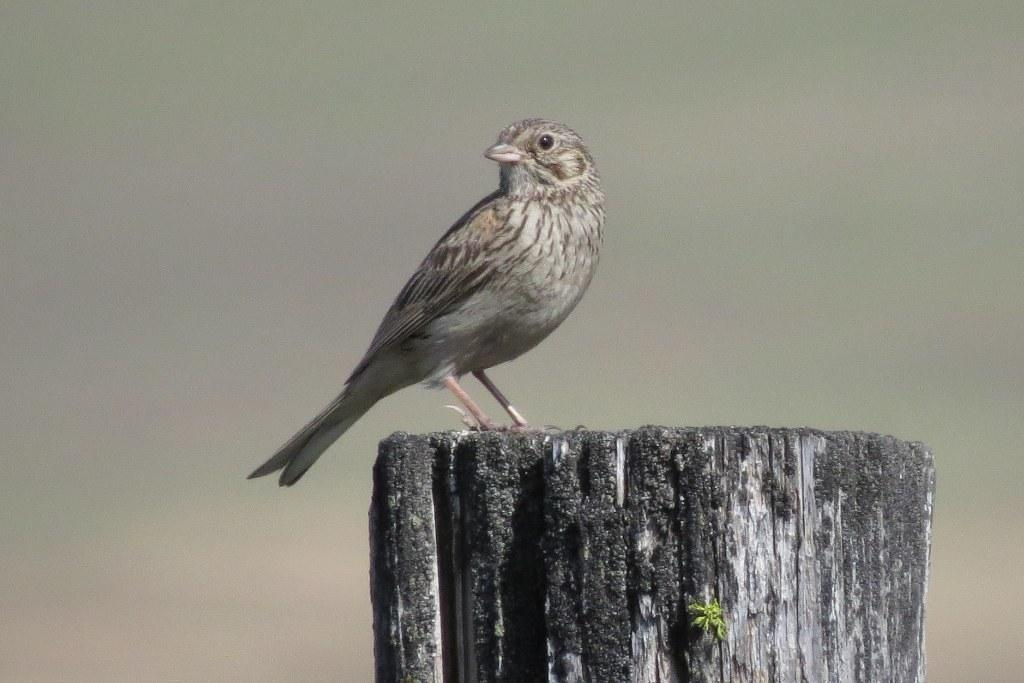What type of animal is in the image? There is a bird in the image. What is the bird standing on? The bird is standing on a wooden block. Can you describe the background of the image? The background of the image is blurry. What type of soap is the bird using to clean itself in the image? There is no soap present in the image, and the bird is not shown cleaning itself. 